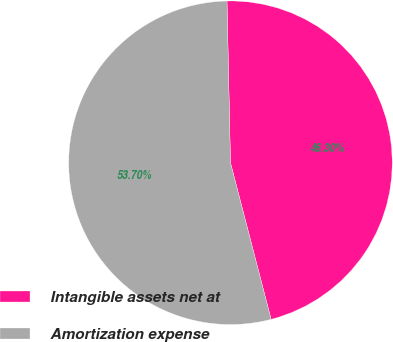<chart> <loc_0><loc_0><loc_500><loc_500><pie_chart><fcel>Intangible assets net at<fcel>Amortization expense<nl><fcel>46.3%<fcel>53.7%<nl></chart> 